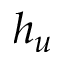<formula> <loc_0><loc_0><loc_500><loc_500>h _ { u }</formula> 